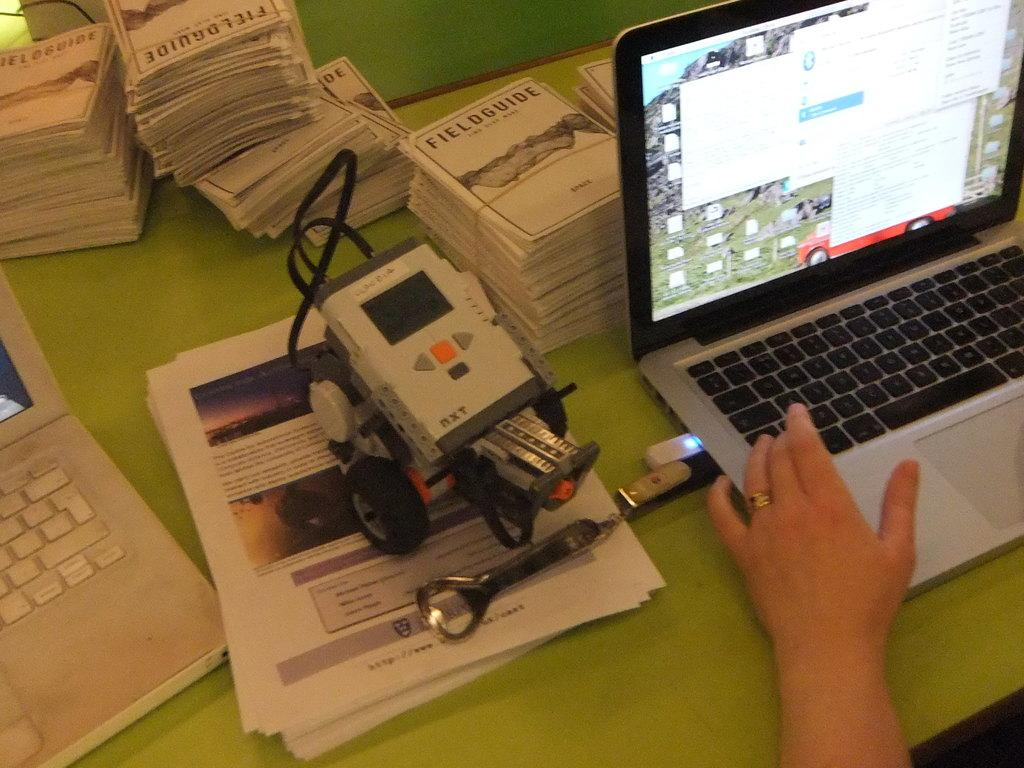<image>
Share a concise interpretation of the image provided. A stack of books titled Fieldguide sits behind a laptop. 